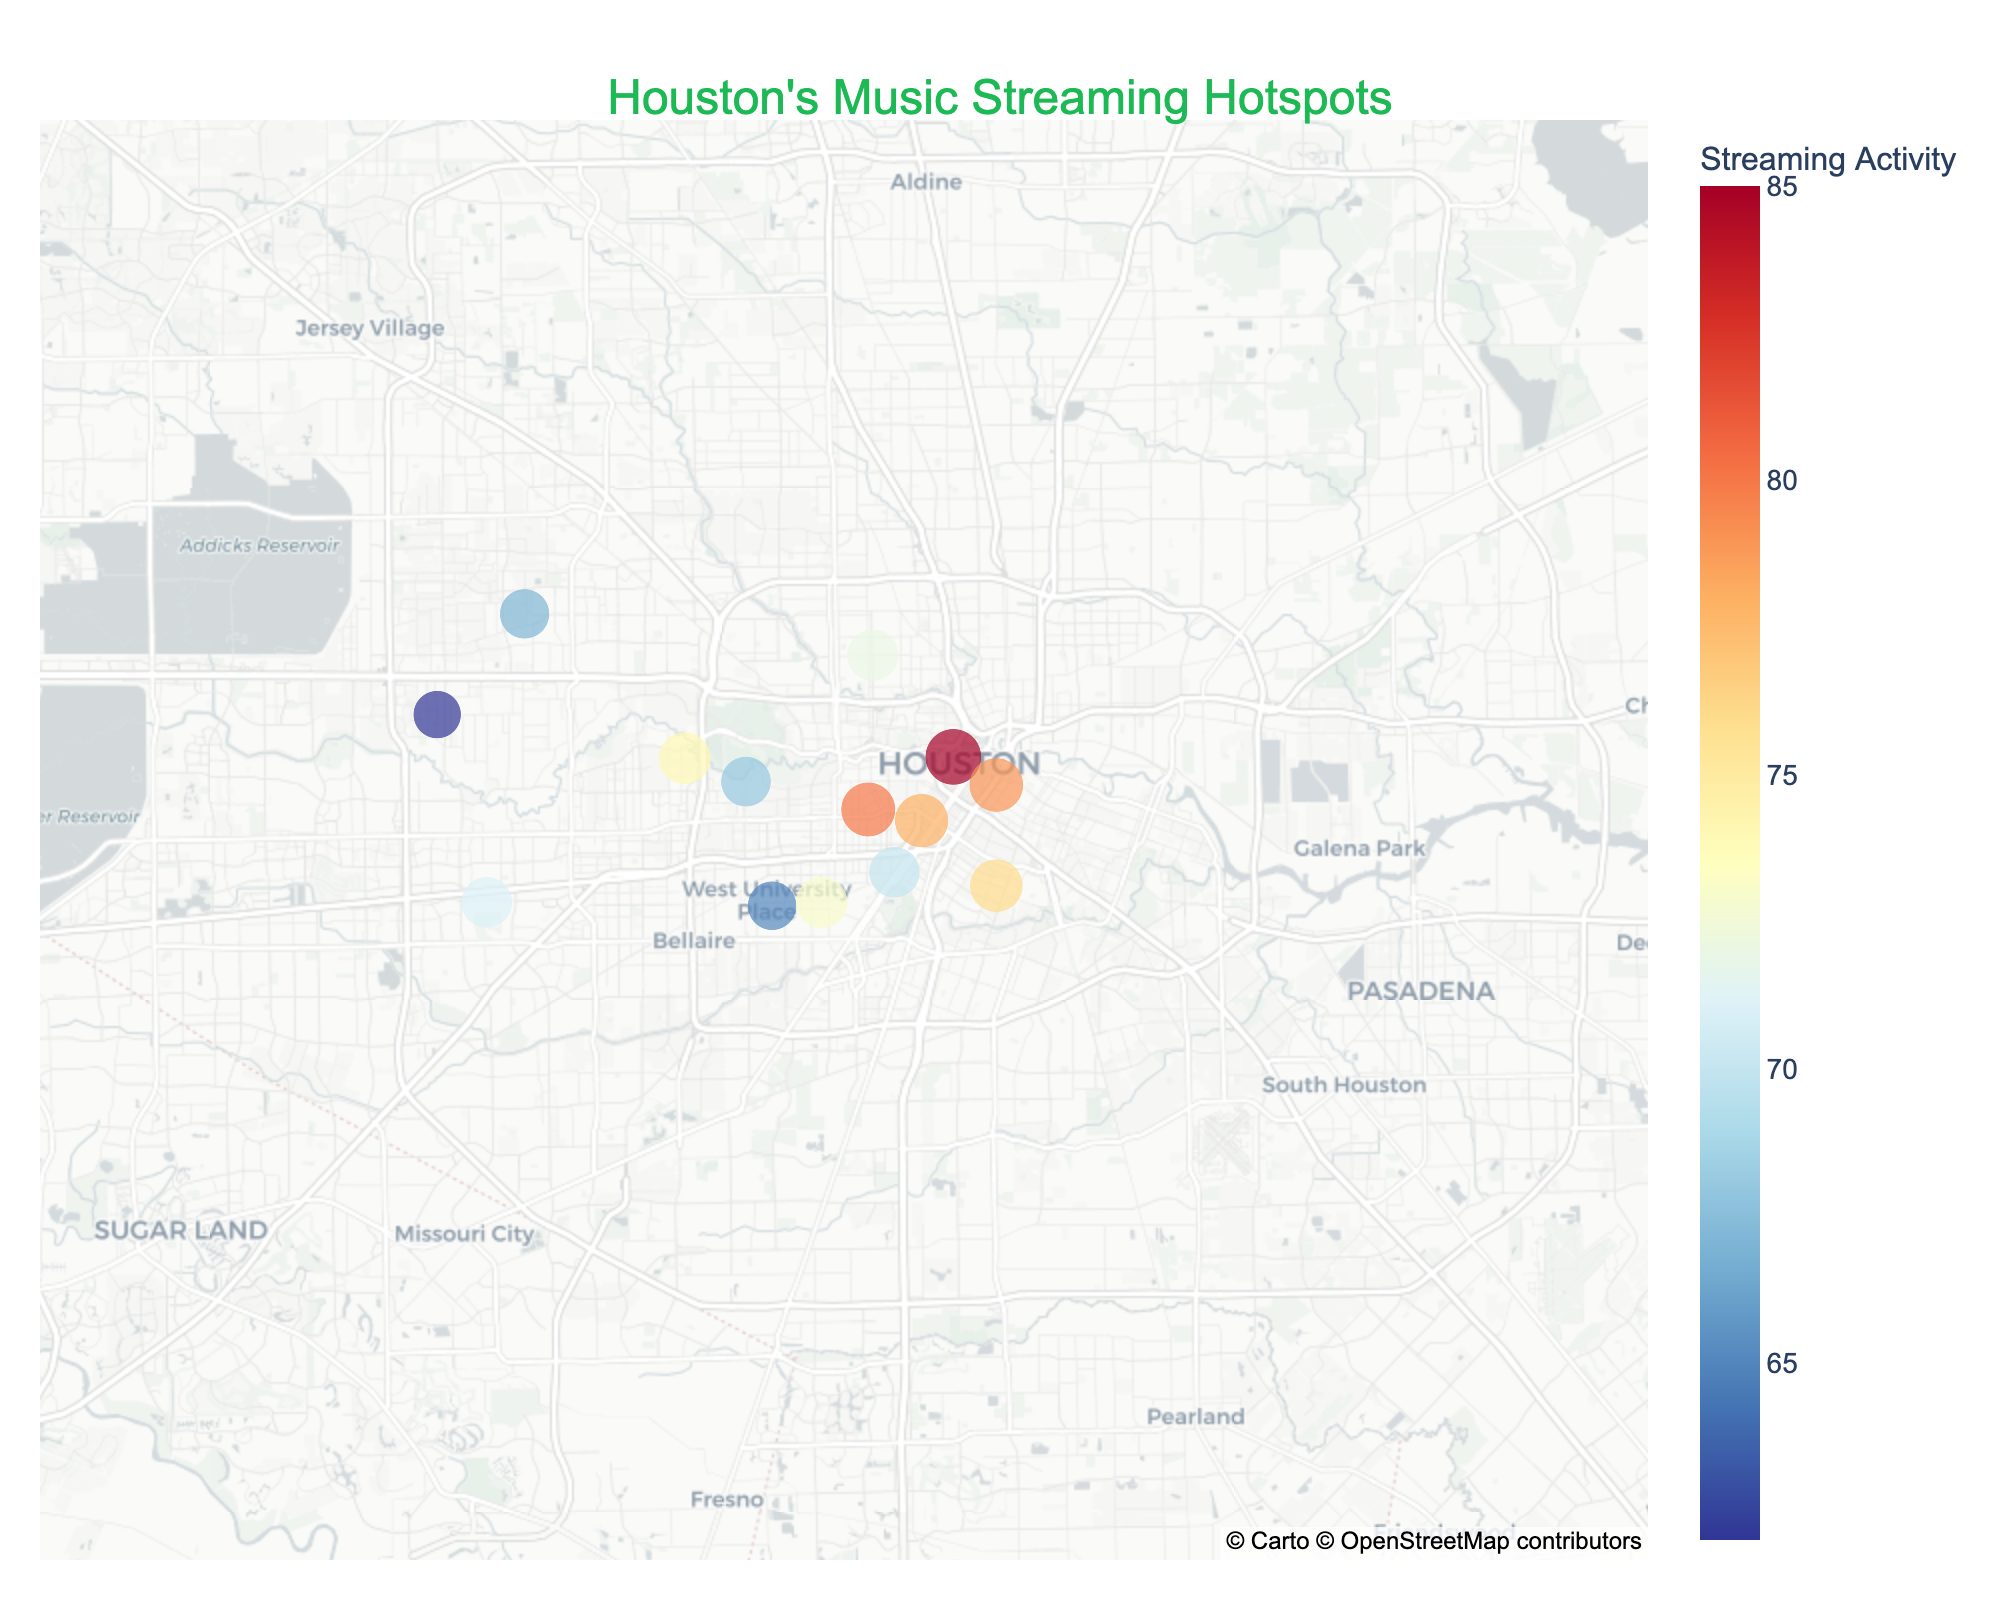What is the title of the figure? The title is usually placed at the top of the figure. It provides a summary of what the visual represents.
Answer: Houston’s Music Streaming Hotspots Which neighborhood has the highest streaming activity? To find this, look at the data points on the map and check the size of the circles. The largest circle represents the highest streaming activity.
Answer: Downtown What is the color scale used in the map? Observing the legend or color bar within the figure shows a range of colors from red to blue indicating the scale of streaming activity.
Answer: Red to blue Which genre is most popular in Midtown? Look at the information provided for the Midtown neighborhood. It includes data on the top genre.
Answer: R&B Compare the streaming activity between Montrose and Midtown. Which one is higher? Check the sizes and color intensities of the circles for Montrose and Midtown. The larger and more intensely colored circle indicates higher streaming activity.
Answer: Montrose What genre is the most frequently top-listed across the neighborhoods shown? Look at the “Top_Genre” for each neighborhood and count the occurrences of each genre.
Answer: Pop Which neighborhood has Post Malone as the top artist? Identify the neighborhood by looking at the annotations or hover data labeling Post Malone as the top artist.
Answer: EaDo How does the streaming activity of River Oaks compare to that of Sharpstown? Compare the sizes and intensities of the circles for River Oaks and Sharpstown. River Oaks has a circle with lesser size and less intense color, indicating lower activity.
Answer: Less than Sharpstown What is the average streaming activity of the neighborhoods? Add up the streaming activities of all neighborhoods and divide by the total number of neighborhoods. (85+78+72+80+68+76+70+65+62+74+79+67+64+71+73)/15.
Answer: 71 Which artist is the top artist in the Museum District? Examine the neighborhood annotations or hover data to find the top artist for the Museum District.
Answer: Coldplay 